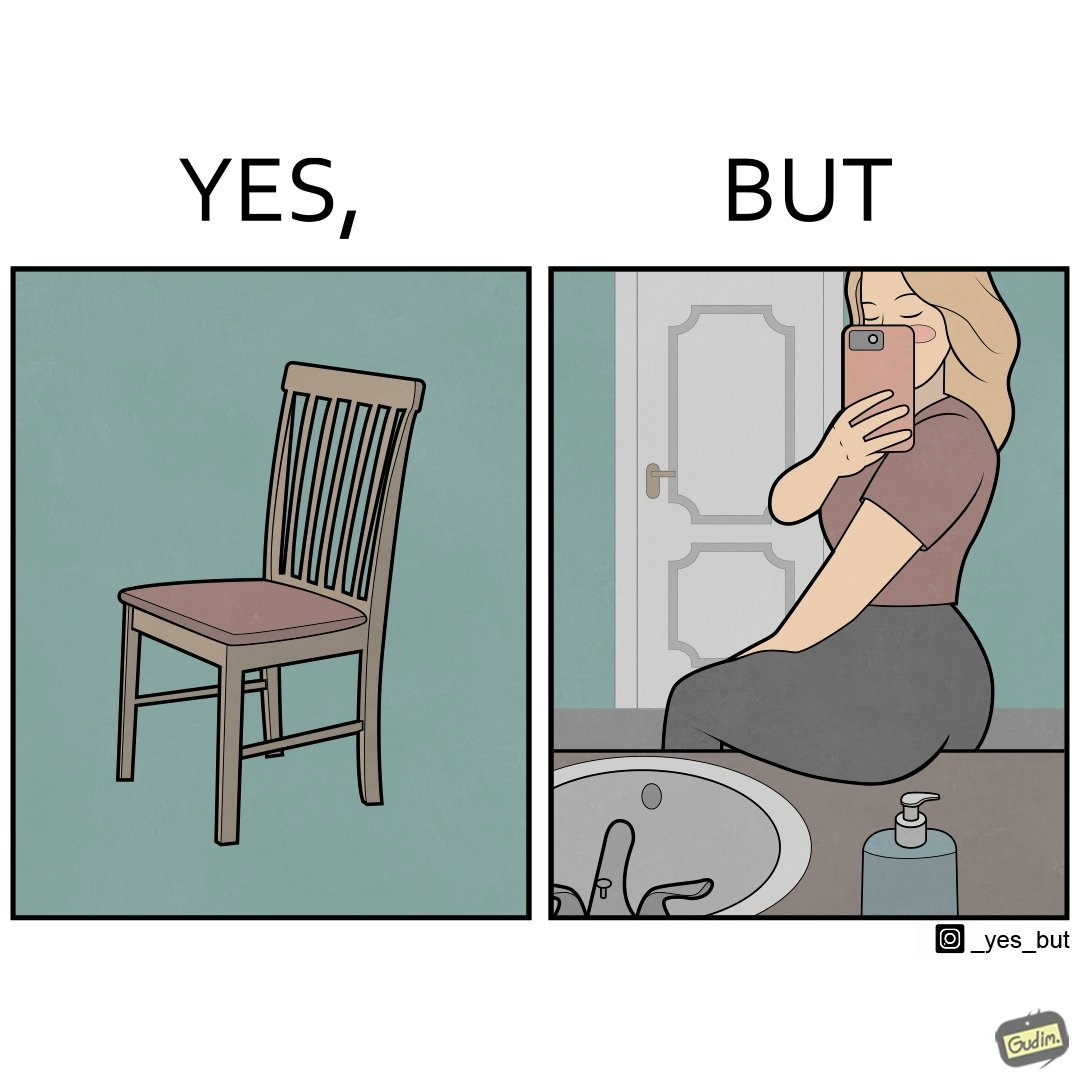Why is this image considered satirical? The image is ironical, as a woman is sitting by the sink taking a selfie using a mirror, while not using a chair that is actually meant for sitting. 